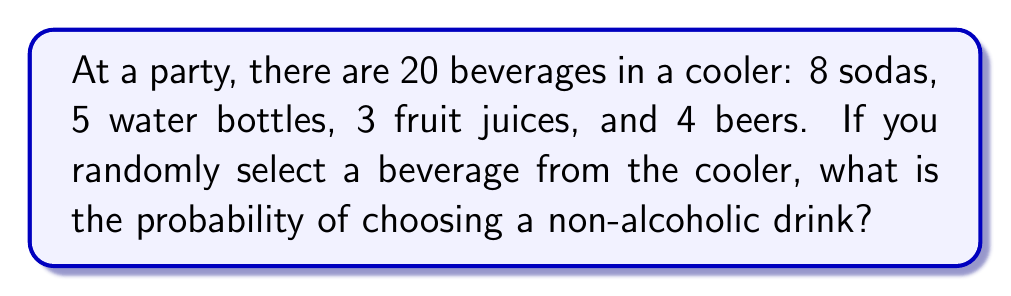Solve this math problem. Let's approach this step-by-step:

1) First, we need to identify the non-alcoholic beverages:
   - Sodas: 8
   - Water bottles: 5
   - Fruit juices: 3

2) Calculate the total number of non-alcoholic beverages:
   $8 + 5 + 3 = 16$

3) The total number of beverages in the cooler is 20.

4) The probability of an event is calculated by:
   $$P(\text{event}) = \frac{\text{number of favorable outcomes}}{\text{total number of possible outcomes}}$$

5) In this case:
   $$P(\text{non-alcoholic}) = \frac{\text{number of non-alcoholic beverages}}{\text{total number of beverages}}$$

6) Substituting the values:
   $$P(\text{non-alcoholic}) = \frac{16}{20}$$

7) Simplify the fraction:
   $$P(\text{non-alcoholic}) = \frac{4}{5} = 0.8$$

Therefore, the probability of selecting a non-alcoholic beverage is $\frac{4}{5}$ or 0.8 or 80%.
Answer: $\frac{4}{5}$ 